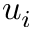Convert formula to latex. <formula><loc_0><loc_0><loc_500><loc_500>u _ { i }</formula> 